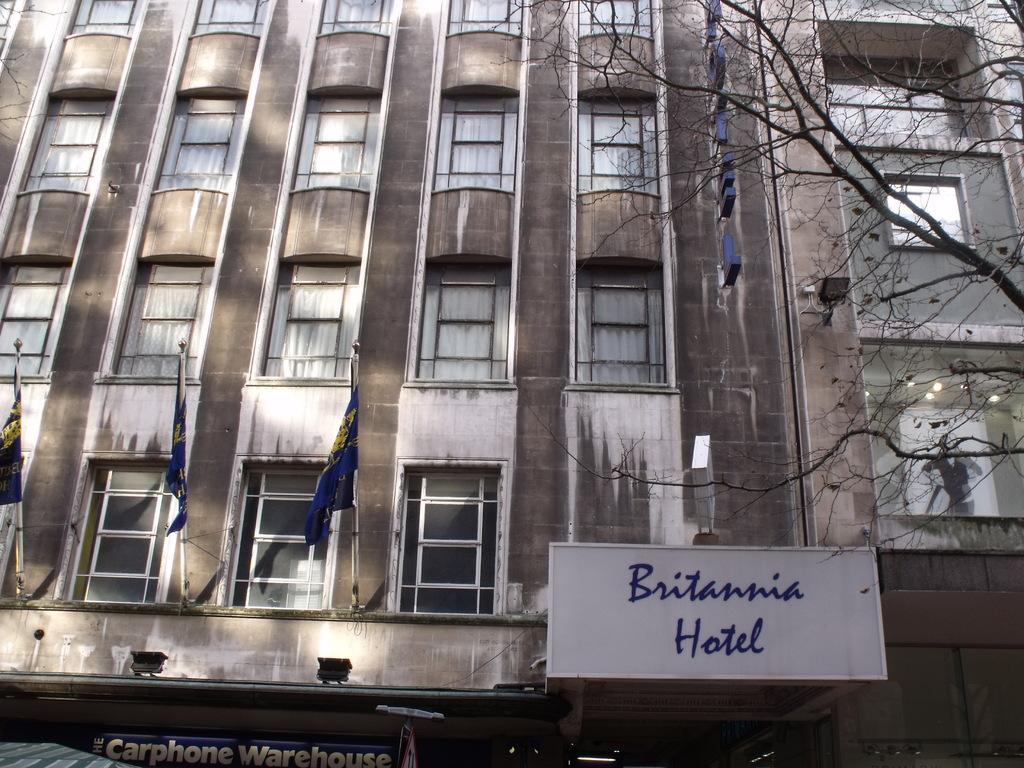How would you summarize this image in a sentence or two? On the right side, we see the trees. In front of the picture, we see a white color board with some text written as "Britannia Hotel". At the bottom, we see a blue color board with some text written. We see the flag poles and the flags in blue and yellow color. In the background, we see the buildings and these buildings have the glass windows. 